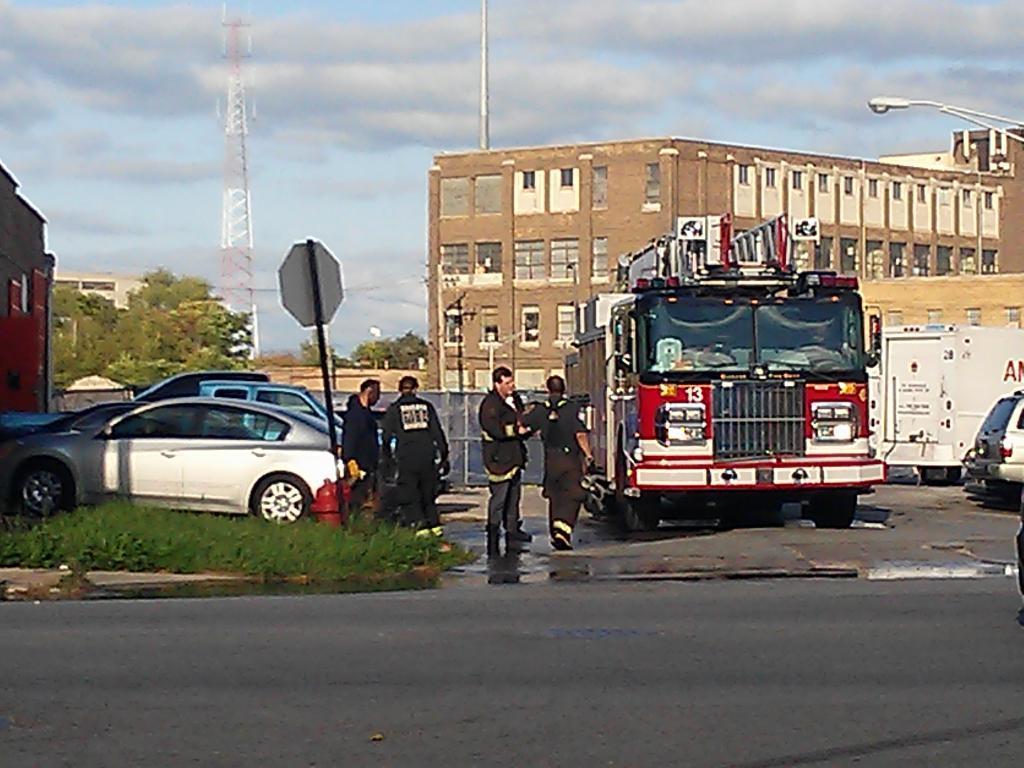Can you describe this image briefly? This image is taken outdoors. At the top of the image there is the sky with clouds. At the bottom of the image there is a road. In the background there are a few trees. There is a signal tower and there is a building. On the left side of the image there is a building and a few cars are parked on the ground. There is a ground with grass on it and there is a signboard. On the right side of the image there are a few buildings. There is a pole and there is a street light. A few vehicles are parked on the road. In the middle of the image a few are standing on the ground and a man is walking on the road. 